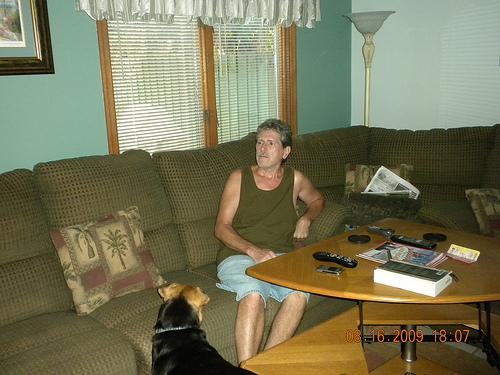Question: where is he?
Choices:
A. On the couch.
B. In the backyard.
C. At the table.
D. At the computer desk.
Answer with the letter. Answer: A Question: what is he sitting on?
Choices:
A. Chair.
B. Bench.
C. Couch.
D. Floor.
Answer with the letter. Answer: C Question: how is the man?
Choices:
A. Happy.
B. Sad.
C. Angry.
D. Relaxed.
Answer with the letter. Answer: D 